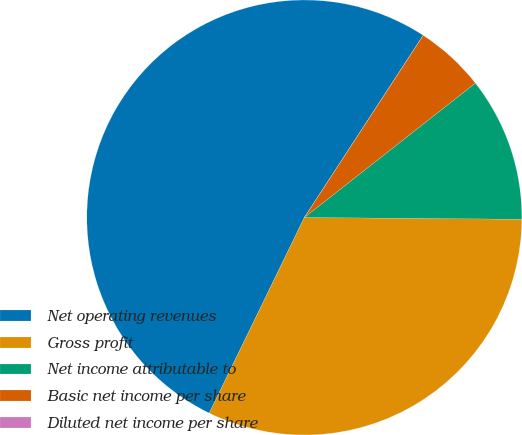<chart> <loc_0><loc_0><loc_500><loc_500><pie_chart><fcel>Net operating revenues<fcel>Gross profit<fcel>Net income attributable to<fcel>Basic net income per share<fcel>Diluted net income per share<nl><fcel>52.0%<fcel>32.07%<fcel>10.73%<fcel>5.2%<fcel>0.0%<nl></chart> 